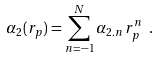<formula> <loc_0><loc_0><loc_500><loc_500>\alpha _ { 2 } ( r _ { p } ) = \sum ^ { N } _ { n = - 1 } \alpha _ { 2 . n } \, r _ { p } ^ { n } \ .</formula> 